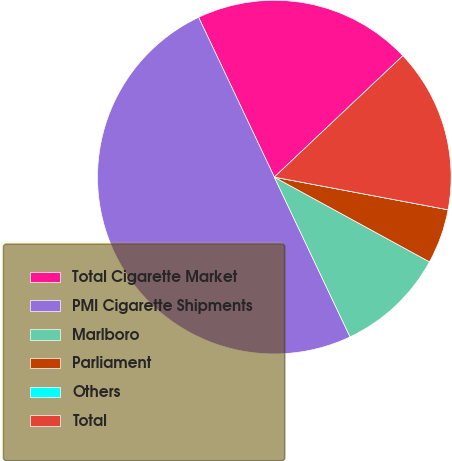<chart> <loc_0><loc_0><loc_500><loc_500><pie_chart><fcel>Total Cigarette Market<fcel>PMI Cigarette Shipments<fcel>Marlboro<fcel>Parliament<fcel>Others<fcel>Total<nl><fcel>20.0%<fcel>50.0%<fcel>10.0%<fcel>5.0%<fcel>0.0%<fcel>15.0%<nl></chart> 